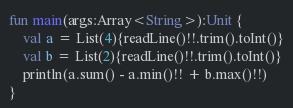<code> <loc_0><loc_0><loc_500><loc_500><_Kotlin_>
fun main(args:Array<String>):Unit {
    val a = List(4){readLine()!!.trim().toInt()}
    val b = List(2){readLine()!!.trim().toInt()}
    println(a.sum() - a.min()!! + b.max()!!)
}
</code> 